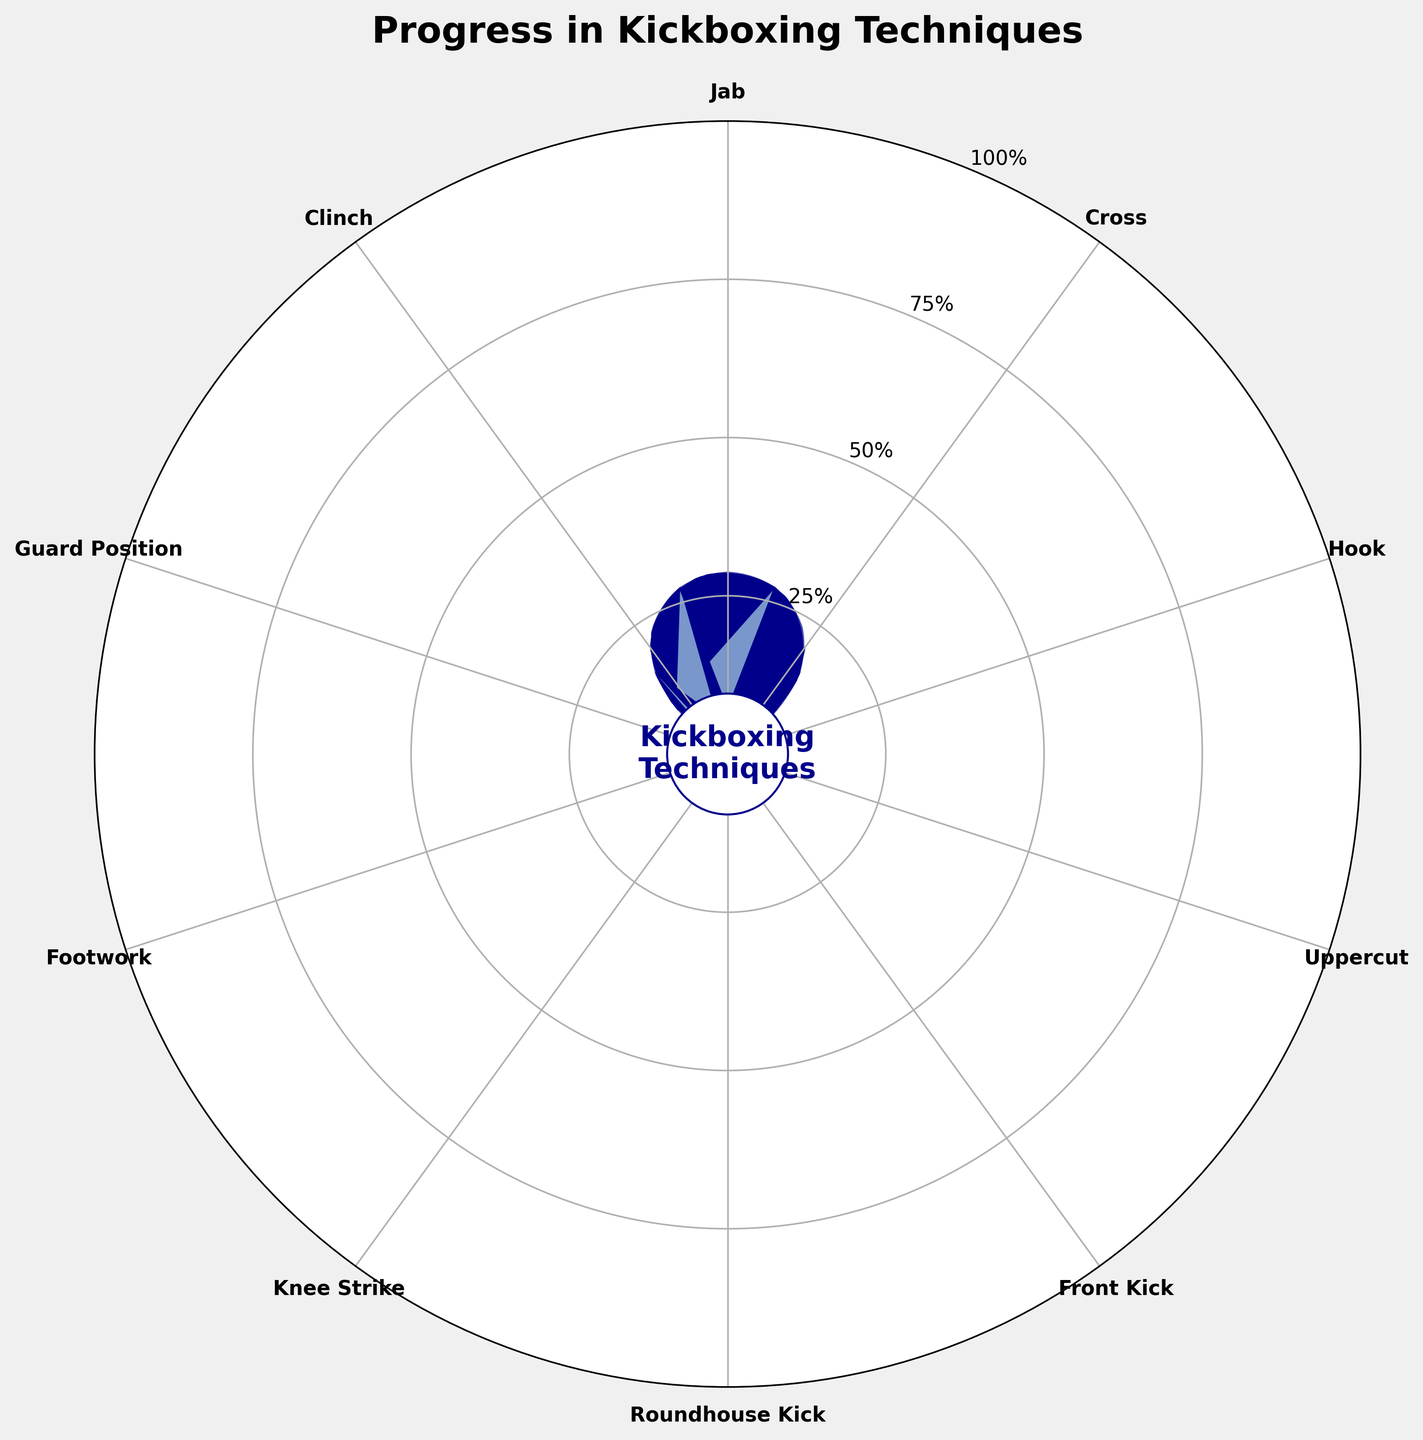Which technique shows the highest progression percentage? The 'Guard Position' shows the highest progression percentage of 80% as indicated by the longest dark blue bar
Answer: Guard Position What percentage progress have you made in mastering the Uppercut? The 'Uppercut' has a progression percentage of 55% which can be seen by looking at the Uppercut section of the plot where the bar extends to just over halfway.
Answer: 55% How many techniques have over 70% progress? The 'Guard Position' (80%), 'Jab' (75%), and 'Front Kick' (70%) have over 70% progress. Count them to get the total number.
Answer: 3 What is the average progress percentage of the Cross and Hook techniques? Cross is 68% and Hook is 62%. Average = (68 + 62)/2 = 65%
Answer: 65% Which technique has the lowest progression percentage? The 'Clinch' has the lowest progression percentage of 45%, evident from the shortest dark blue bar.
Answer: Clinch Compare the progress in Footwork to the progress in Uppercut. Which one has a higher percentage? The 'Footwork' has a progression percentage of 65% while the 'Uppercut' has 55%. Therefore, 'Footwork' has a higher percentage.
Answer: Footwork What is the combined progress percentage of Jab, Uppercut, and Guard Position? Jab: 75%, Uppercut: 55%, Guard Position: 80%. Combined percentage = 75 + 55 + 80 = 210%
Answer: 210% Which technique's progression is exactly 70%? The 'Front Kick' has a progression percentage of 70%, as indicated by its bar.
Answer: Front Kick What is the total number of kickboxing techniques being tracked? The title of the figure and the number of wedges (or sections) on the chart both indicate there are 10 techniques.
Answer: 10 Is the progression in Cross more or less than the progression in Roundhouse Kick? The 'Cross' has a progression of 68% whereas the 'Roundhouse Kick' has 58%. Thus, 'Cross' has more progression.
Answer: More 